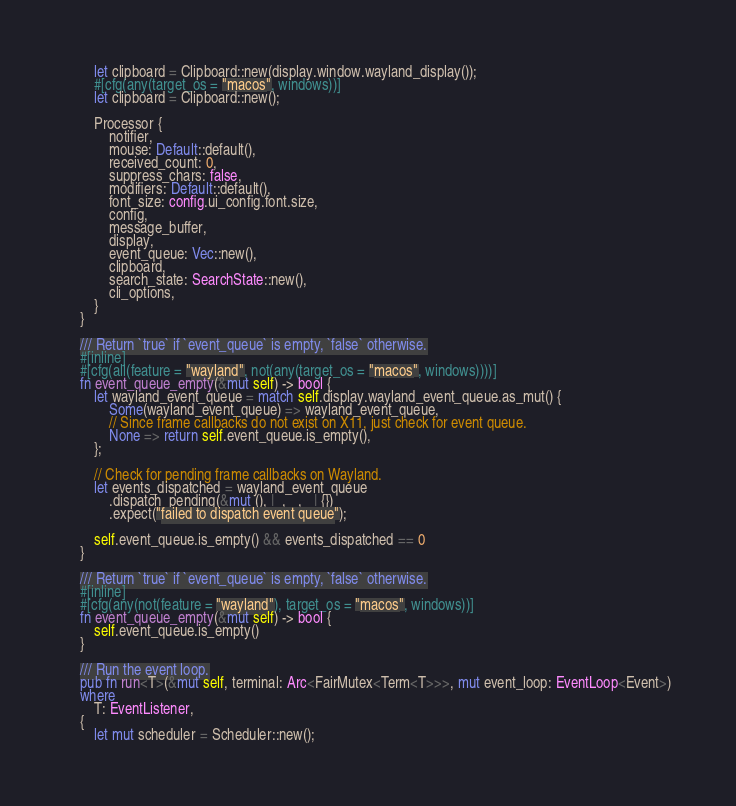Convert code to text. <code><loc_0><loc_0><loc_500><loc_500><_Rust_>        let clipboard = Clipboard::new(display.window.wayland_display());
        #[cfg(any(target_os = "macos", windows))]
        let clipboard = Clipboard::new();

        Processor {
            notifier,
            mouse: Default::default(),
            received_count: 0,
            suppress_chars: false,
            modifiers: Default::default(),
            font_size: config.ui_config.font.size,
            config,
            message_buffer,
            display,
            event_queue: Vec::new(),
            clipboard,
            search_state: SearchState::new(),
            cli_options,
        }
    }

    /// Return `true` if `event_queue` is empty, `false` otherwise.
    #[inline]
    #[cfg(all(feature = "wayland", not(any(target_os = "macos", windows))))]
    fn event_queue_empty(&mut self) -> bool {
        let wayland_event_queue = match self.display.wayland_event_queue.as_mut() {
            Some(wayland_event_queue) => wayland_event_queue,
            // Since frame callbacks do not exist on X11, just check for event queue.
            None => return self.event_queue.is_empty(),
        };

        // Check for pending frame callbacks on Wayland.
        let events_dispatched = wayland_event_queue
            .dispatch_pending(&mut (), |_, _, _| {})
            .expect("failed to dispatch event queue");

        self.event_queue.is_empty() && events_dispatched == 0
    }

    /// Return `true` if `event_queue` is empty, `false` otherwise.
    #[inline]
    #[cfg(any(not(feature = "wayland"), target_os = "macos", windows))]
    fn event_queue_empty(&mut self) -> bool {
        self.event_queue.is_empty()
    }

    /// Run the event loop.
    pub fn run<T>(&mut self, terminal: Arc<FairMutex<Term<T>>>, mut event_loop: EventLoop<Event>)
    where
        T: EventListener,
    {
        let mut scheduler = Scheduler::new();
</code> 